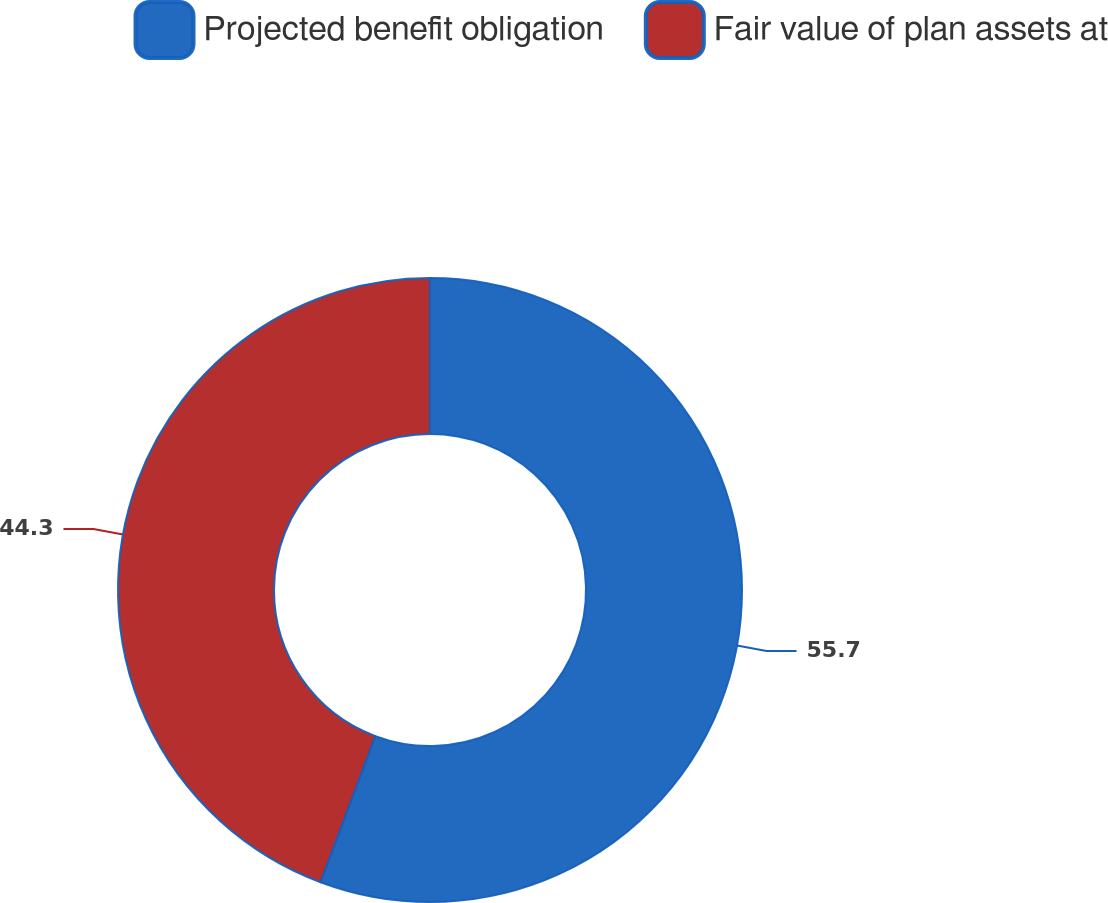Convert chart. <chart><loc_0><loc_0><loc_500><loc_500><pie_chart><fcel>Projected benefit obligation<fcel>Fair value of plan assets at<nl><fcel>55.7%<fcel>44.3%<nl></chart> 